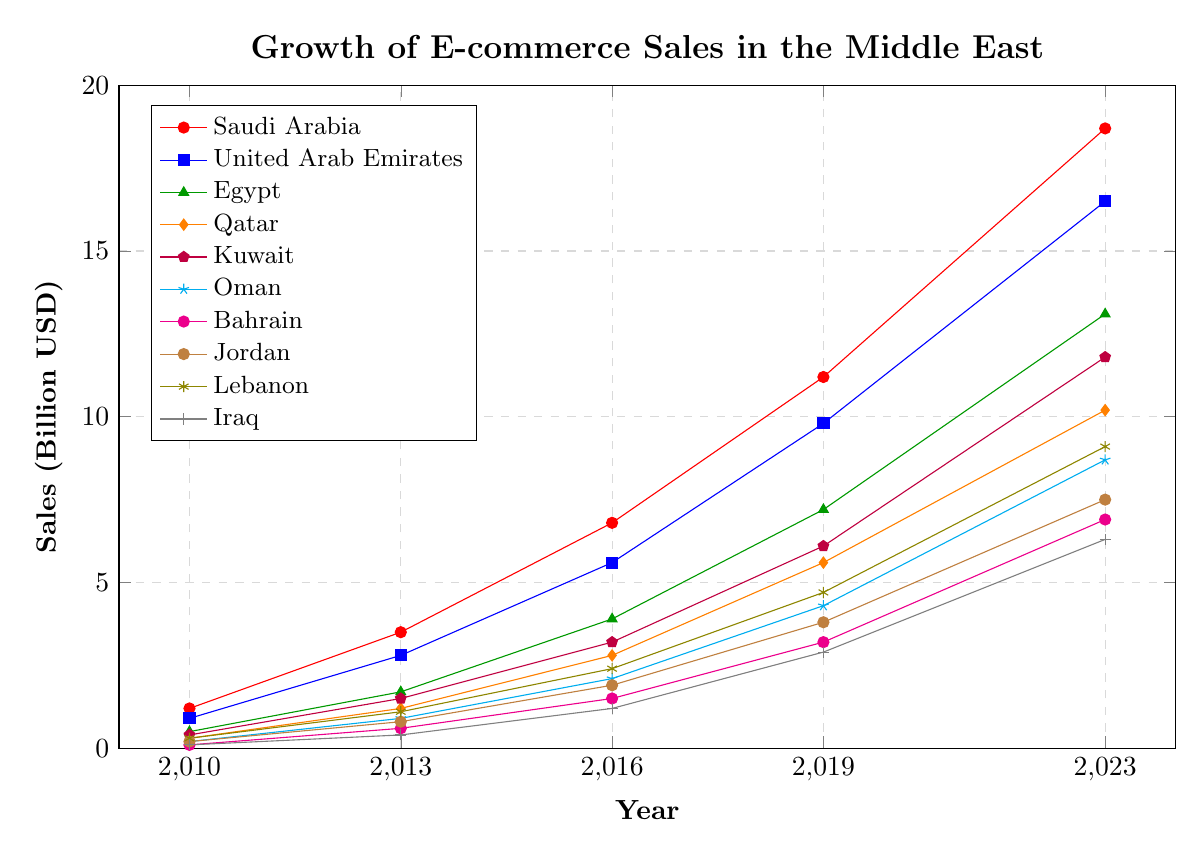What's the overall trend of e-commerce sales in the Middle East from 2010 to 2023? From 2010 to 2023, the trend for e-commerce sales in all plotted Middle Eastern countries is consistently rising. Each country shows significant sales increase over the time period, indicating a strong growth trend for e-commerce in the region.
Answer: Increasing Which country had the highest e-commerce sales in 2023? By looking at the plot, the country with the highest point on the y-axis in 2023 is evident. Saudi Arabia, with sales reaching 18.7 billion USD, has the highest e-commerce sales in 2023.
Answer: Saudi Arabia Which country experienced the highest growth in e-commerce sales from 2010 to 2023? To find the highest growth, we subtract the 2010 value from the 2023 value for each country. Saudi Arabia increased from 1.2 billion USD to 18.7 billion USD, which is an increase of 17.5 billion USD, the largest among the countries listed.
Answer: Saudi Arabia Between 2016 and 2023, which country had the fastest rate of growth in e-commerce sales? The rate of growth can be determined by the difference in sales between 2023 and 2016. Saudi Arabia went from 6.8 to 18.7 billion USD (a 11.9 billion USD increase), while other countries had smaller increases. Therefore, Saudi Arabia had the fastest rate of growth.
Answer: Saudi Arabia Compare the e-commerce sales growth between Egypt and Qatar in 2023. Which country saw higher growth? Calculating the growth for Egypt and Qatar from 2010 to 2023, we see Egypt grew from 0.5 to 13.1 billion USD and Qatar from 0.3 to 10.2 billion USD. The growth for Egypt is 12.6 billion USD and for Qatar is 9.9 billion USD. Therefore, Egypt saw higher growth.
Answer: Egypt What was the total e-commerce sales for Bahrain across all years presented? We calculate the total by summing all the values for Bahrain: 0.1 (2010) + 0.6 (2013) + 1.5 (2016) + 3.2 (2019) + 6.9 (2023) which equals 12.3 billion USD.
Answer: 12.3 billion USD Compare the e-commerce sales for Iraq and Lebanon in 2019. Which country had higher sales? In 2019, Iraq had sales of 2.9 billion USD, while Lebanon had sales of 4.7 billion USD. By comparing these values, we see that Lebanon had higher sales.
Answer: Lebanon Between 2010 and 2023, which country had the smallest absolute increase in e-commerce sales? Calculating the growth from 2010 to 2023 for each country, Iraq grew from 0.1 to 6.3 billion USD, which is an increase of 6.2 billion USD. This is the smallest absolute increase among the countries listed.
Answer: Iraq In which year did Kuwait’s e-commerce sales first exceed 6 billion USD? By examining the plotted data points for Kuwait, its sales exceeded 6 billion USD in 2019, where it recorded 6.1 billion USD.
Answer: 2019 